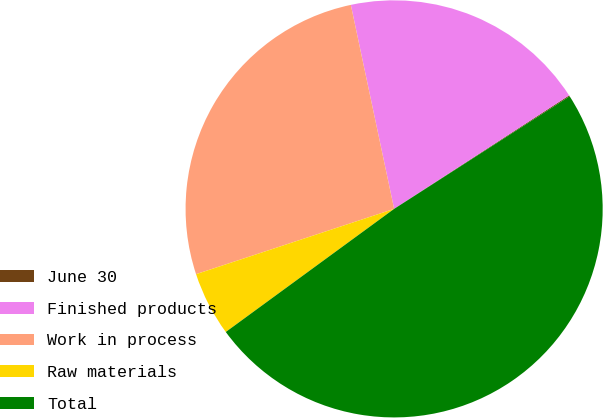<chart> <loc_0><loc_0><loc_500><loc_500><pie_chart><fcel>June 30<fcel>Finished products<fcel>Work in process<fcel>Raw materials<fcel>Total<nl><fcel>0.08%<fcel>19.17%<fcel>26.74%<fcel>4.98%<fcel>49.03%<nl></chart> 